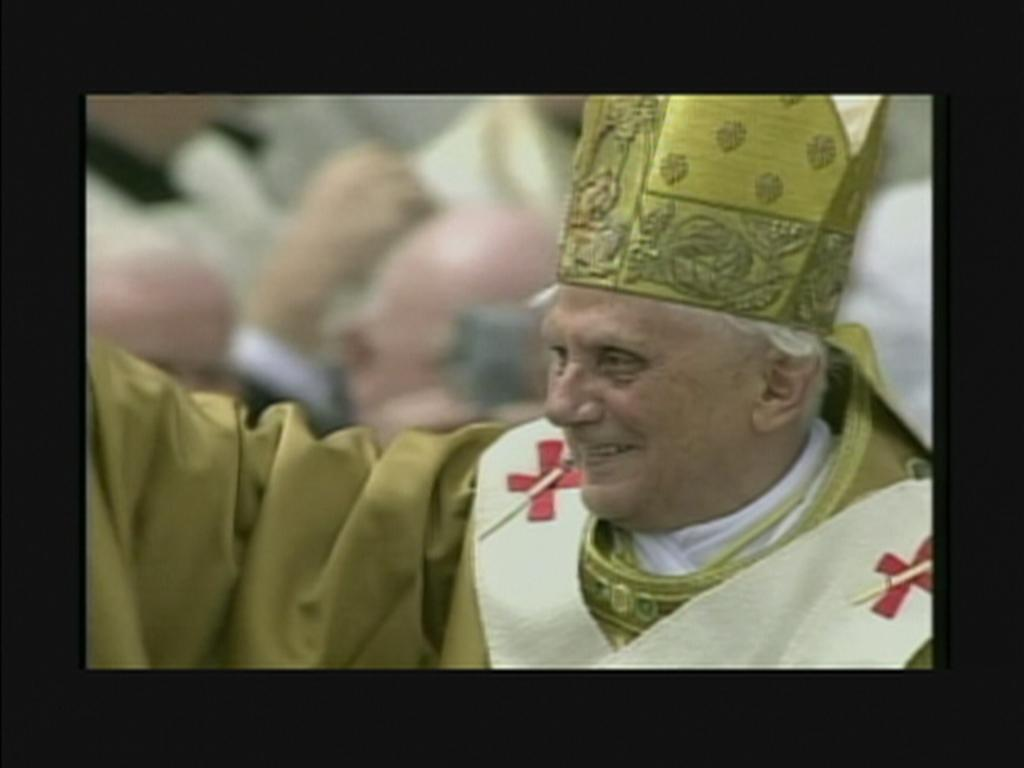What is the main subject of the image? There is a man in the image. What is the man's facial expression? The man is smiling. Can you describe the background of the image? The background of the image appears blurry. What type of writing can be seen on the man's scarf in the image? There is no scarf present in the image, and therefore no writing on it. 